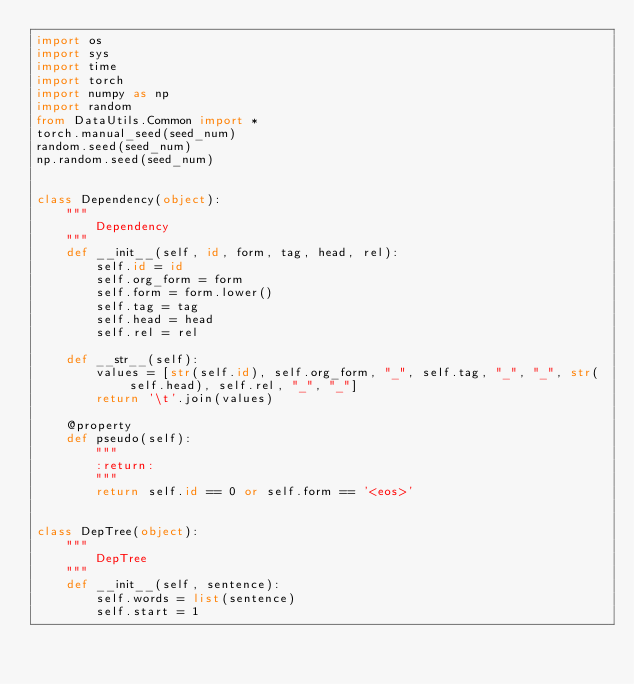<code> <loc_0><loc_0><loc_500><loc_500><_Python_>import os
import sys
import time
import torch
import numpy as np
import random
from DataUtils.Common import *
torch.manual_seed(seed_num)
random.seed(seed_num)
np.random.seed(seed_num)


class Dependency(object):
    """
        Dependency
    """
    def __init__(self, id, form, tag, head, rel):
        self.id = id
        self.org_form = form
        self.form = form.lower()
        self.tag = tag
        self.head = head
        self.rel = rel

    def __str__(self):
        values = [str(self.id), self.org_form, "_", self.tag, "_", "_", str(self.head), self.rel, "_", "_"]
        return '\t'.join(values)

    @property
    def pseudo(self):
        """
        :return:
        """
        return self.id == 0 or self.form == '<eos>'


class DepTree(object):
    """
        DepTree
    """
    def __init__(self, sentence):
        self.words = list(sentence)
        self.start = 1</code> 